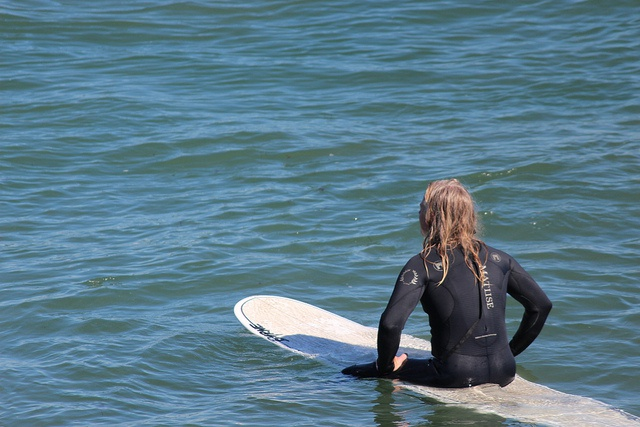Describe the objects in this image and their specific colors. I can see people in gray and black tones, surfboard in gray, lightgray, and darkgray tones, and surfboard in gray, lightgray, and darkgray tones in this image. 